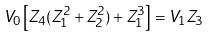<formula> <loc_0><loc_0><loc_500><loc_500>V _ { 0 } \left [ Z _ { 4 } ( Z _ { 1 } ^ { 2 } + Z _ { 2 } ^ { 2 } ) + Z _ { 1 } ^ { 3 } \right ] = V _ { 1 } Z _ { 3 }</formula> 